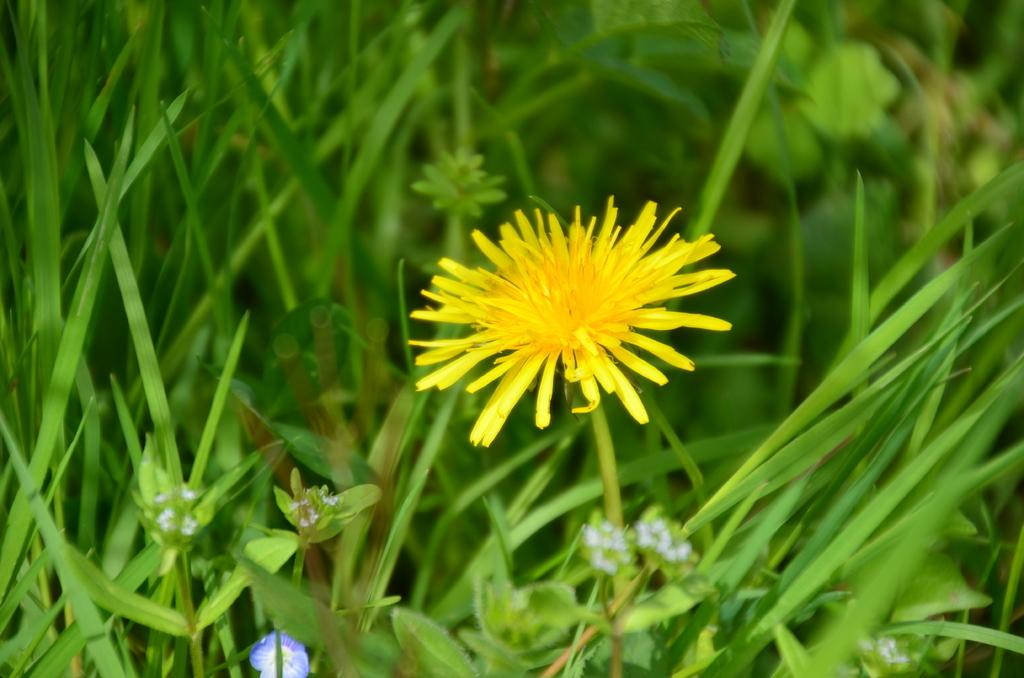What is the main subject in the center of the image? There is a flower in the center of the image. What type of vegetation can be seen in the image? There is grass in the image. What type of flag is visible in the image? There is no flag present in the image. What kind of structure can be seen in the image? There is no structure present in the image; it only features a flower and grass. 